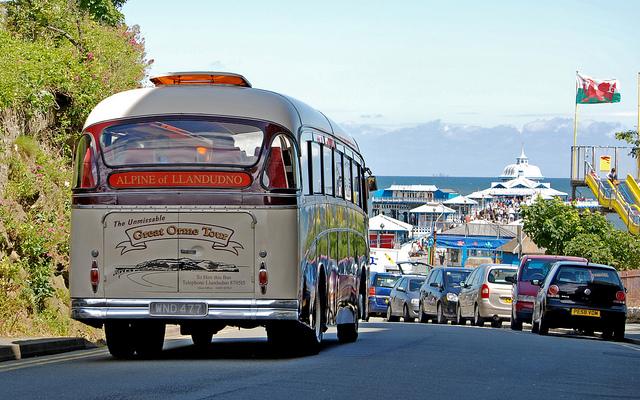What is on top of the bus?
Write a very short answer. Sunroof. What kind of town is this?
Be succinct. Beach. What is the color of the bus?
Answer briefly. White. Sunny or overcast?
Be succinct. Sunny. 